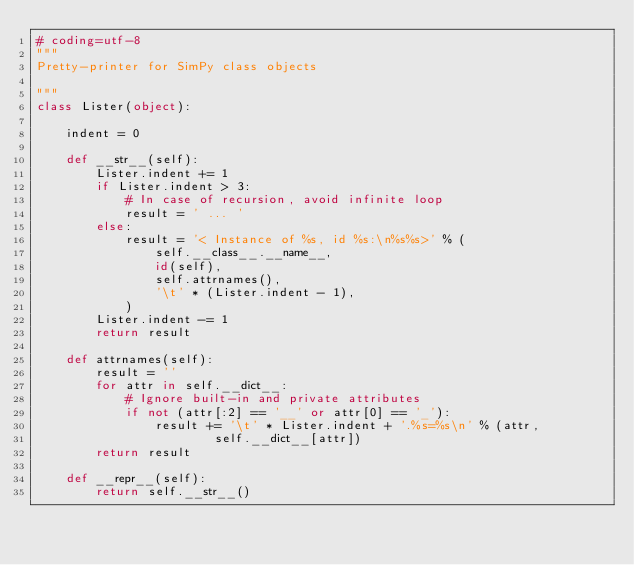<code> <loc_0><loc_0><loc_500><loc_500><_Python_># coding=utf-8
"""
Pretty-printer for SimPy class objects

"""
class Lister(object):

    indent = 0

    def __str__(self):
        Lister.indent += 1
        if Lister.indent > 3:
            # In case of recursion, avoid infinite loop
            result = ' ... '
        else:
            result = '< Instance of %s, id %s:\n%s%s>' % (
                self.__class__.__name__,
                id(self),
                self.attrnames(),
                '\t' * (Lister.indent - 1),
            )
        Lister.indent -= 1
        return result

    def attrnames(self):
        result = ''
        for attr in self.__dict__:
            # Ignore built-in and private attributes
            if not (attr[:2] == '__' or attr[0] == '_'):
                result += '\t' * Lister.indent + '.%s=%s\n' % (attr,
                        self.__dict__[attr])
        return result

    def __repr__(self):
        return self.__str__()
</code> 